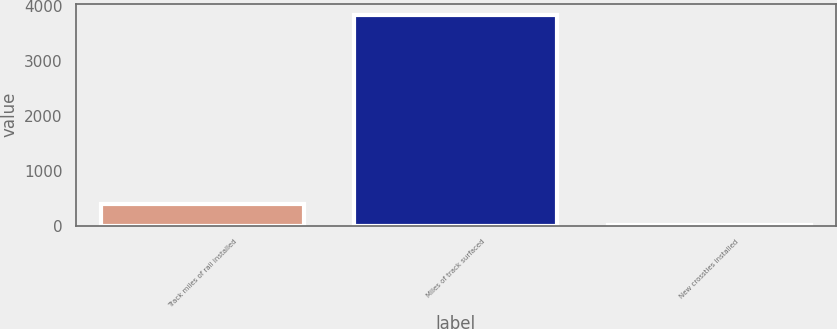Convert chart to OTSL. <chart><loc_0><loc_0><loc_500><loc_500><bar_chart><fcel>Track miles of rail installed<fcel>Miles of track surfaced<fcel>New crossties installed<nl><fcel>384.95<fcel>3836<fcel>1.5<nl></chart> 